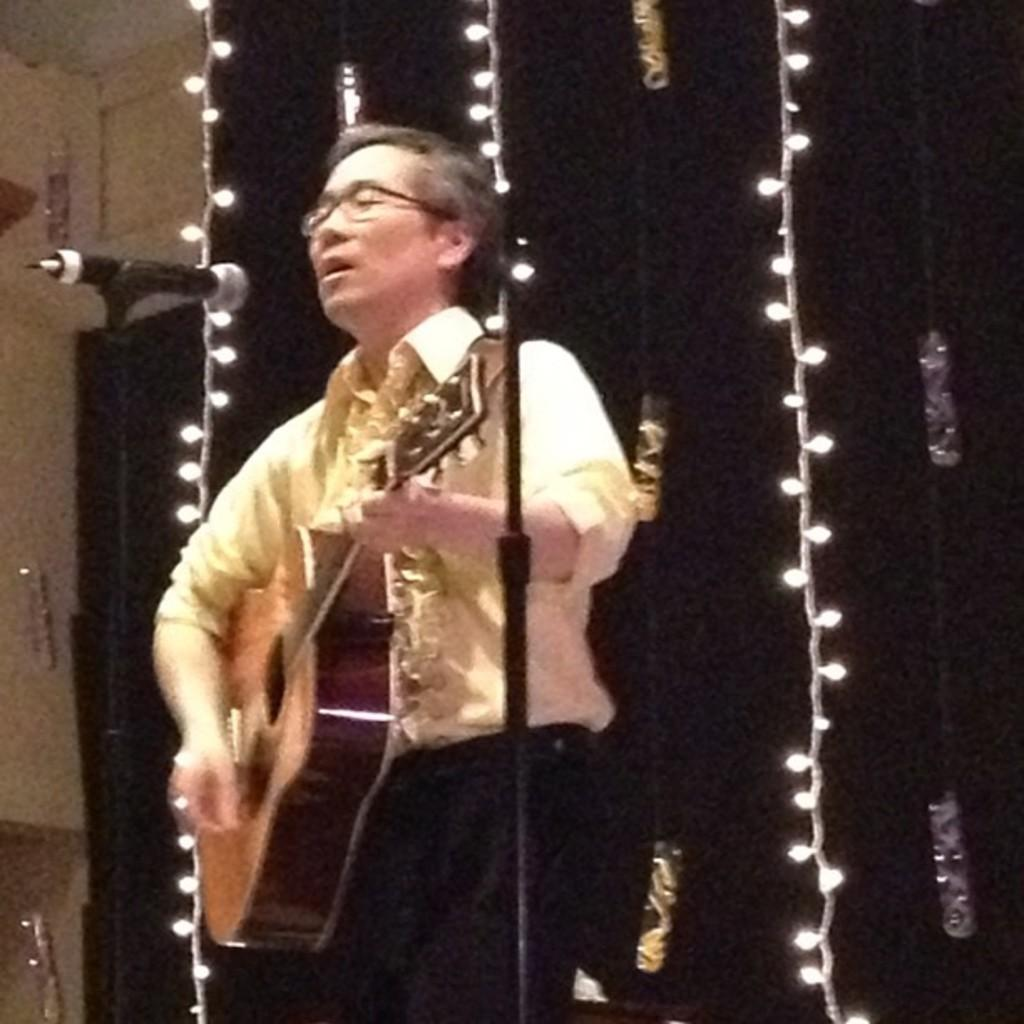What is the man in the image doing? The man is playing a guitar and singing a song. How is the man amplifying his voice in the image? The man is using a microphone. What can be seen in the background of the image? There are lights and a cloth in the background. What type of bread is the man using as a rhythm instrument in the image? There is no bread present in the image, and the man is not using any rhythm instrument. 